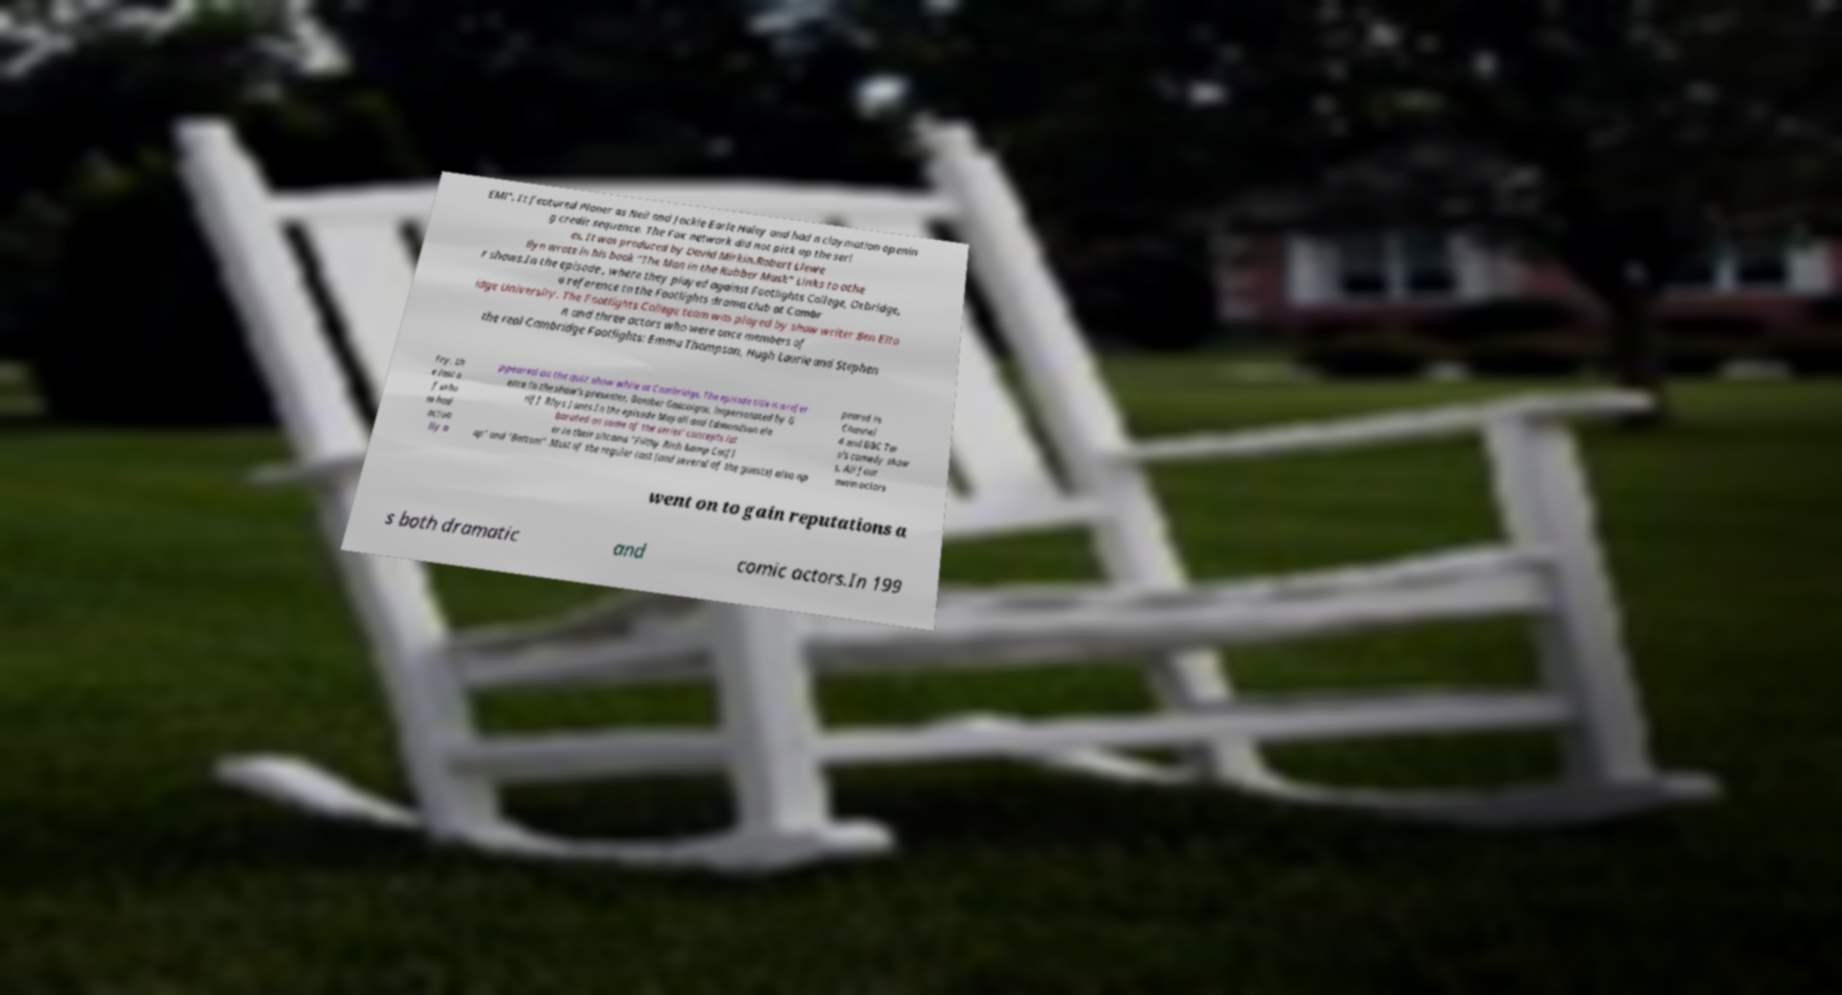Can you read and provide the text displayed in the image?This photo seems to have some interesting text. Can you extract and type it out for me? EM!". It featured Planer as Neil and Jackie Earle Haley and had a claymation openin g credit sequence. The Fox network did not pick up the seri es. It was produced by David Mirkin.Robert Llewe llyn wrote in his book "The Man in the Rubber Mask" Links to othe r shows.In the episode , where they played against Footlights College, Oxbridge, a reference to the Footlights drama club at Cambr idge University. The Footlights College team was played by show writer Ben Elto n and three actors who were once members of the real Cambridge Footlights: Emma Thompson, Hugh Laurie and Stephen Fry, th e last o f who m had actua lly a ppeared on the quiz show while at Cambridge. The episode title is a refer ence to the show's presenter, Bamber Gascoigne, impersonated by G riff Rhys Jones.In the episode Mayall and Edmondson ela borated on some of the series' concepts lat er in their sitcoms "Filthy Rich &amp Catfl ap" and "Bottom" .Most of the regular cast (and several of the guests) also ap peared in Channel 4 and BBC Tw o's comedy show s. All four main actors went on to gain reputations a s both dramatic and comic actors.In 199 